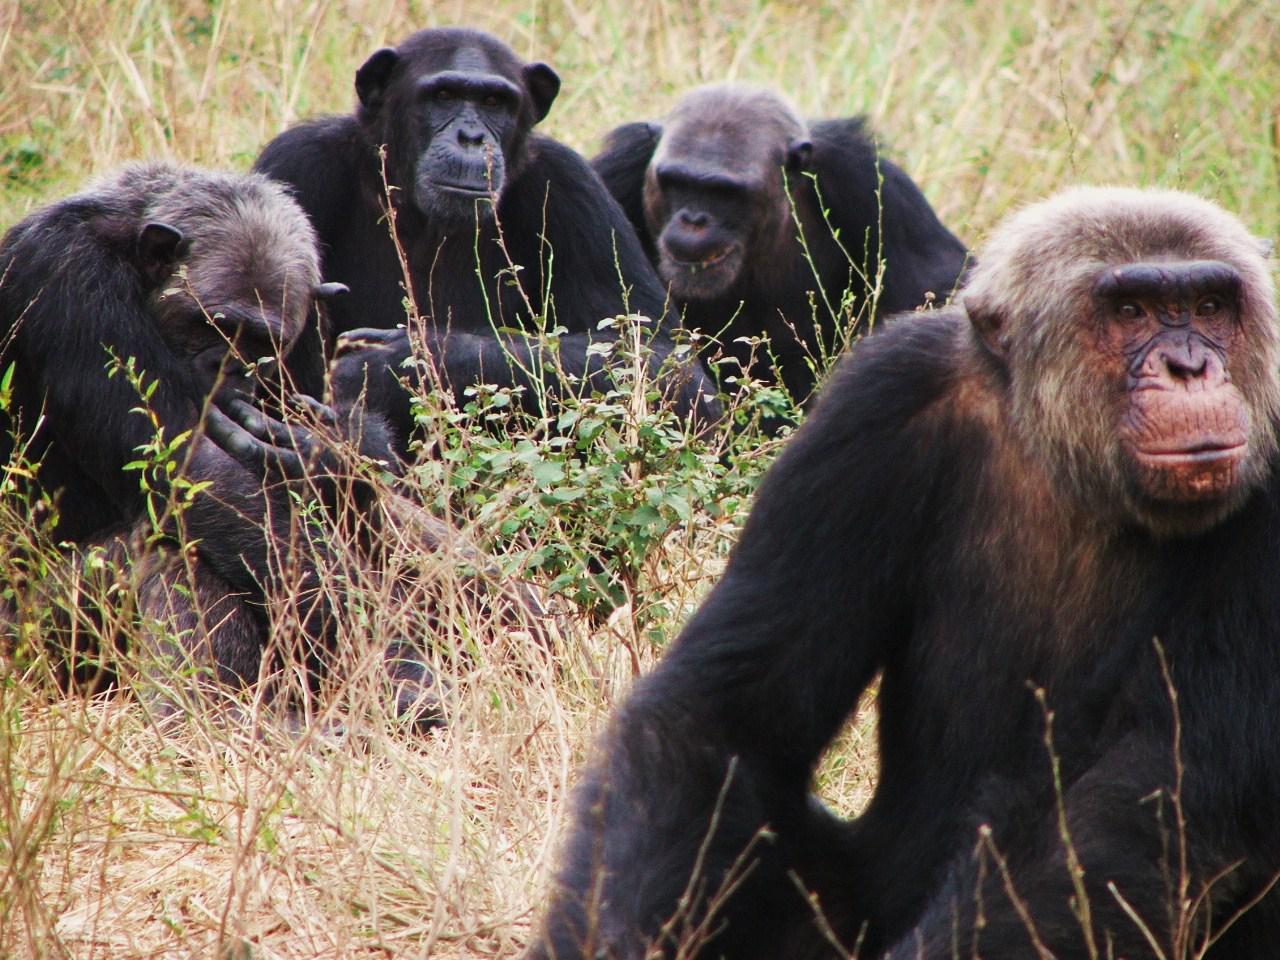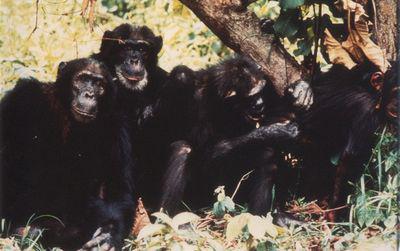The first image is the image on the left, the second image is the image on the right. Assess this claim about the two images: "Left image contains no more than four chimps, including a close trio.". Correct or not? Answer yes or no. Yes. 